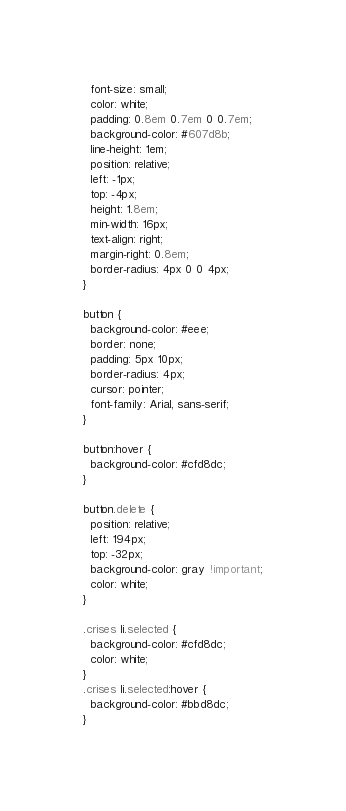<code> <loc_0><loc_0><loc_500><loc_500><_CSS_>  font-size: small;
  color: white;
  padding: 0.8em 0.7em 0 0.7em;
  background-color: #607d8b;
  line-height: 1em;
  position: relative;
  left: -1px;
  top: -4px;
  height: 1.8em;
  min-width: 16px;
  text-align: right;
  margin-right: 0.8em;
  border-radius: 4px 0 0 4px;
}

button {
  background-color: #eee;
  border: none;
  padding: 5px 10px;
  border-radius: 4px;
  cursor: pointer;
  font-family: Arial, sans-serif;
}

button:hover {
  background-color: #cfd8dc;
}

button.delete {
  position: relative;
  left: 194px;
  top: -32px;
  background-color: gray !important;
  color: white;
}

.crises li.selected {
  background-color: #cfd8dc;
  color: white;
}
.crises li.selected:hover {
  background-color: #bbd8dc;
}
</code> 